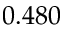<formula> <loc_0><loc_0><loc_500><loc_500>0 . 4 8 0</formula> 